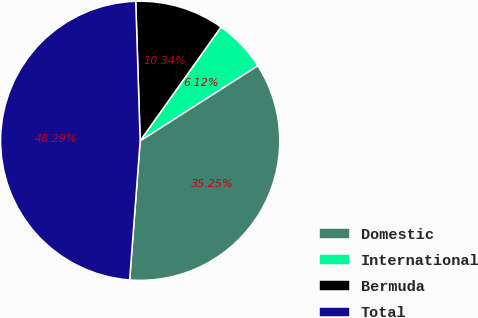Convert chart to OTSL. <chart><loc_0><loc_0><loc_500><loc_500><pie_chart><fcel>Domestic<fcel>International<fcel>Bermuda<fcel>Total<nl><fcel>35.25%<fcel>6.12%<fcel>10.34%<fcel>48.29%<nl></chart> 